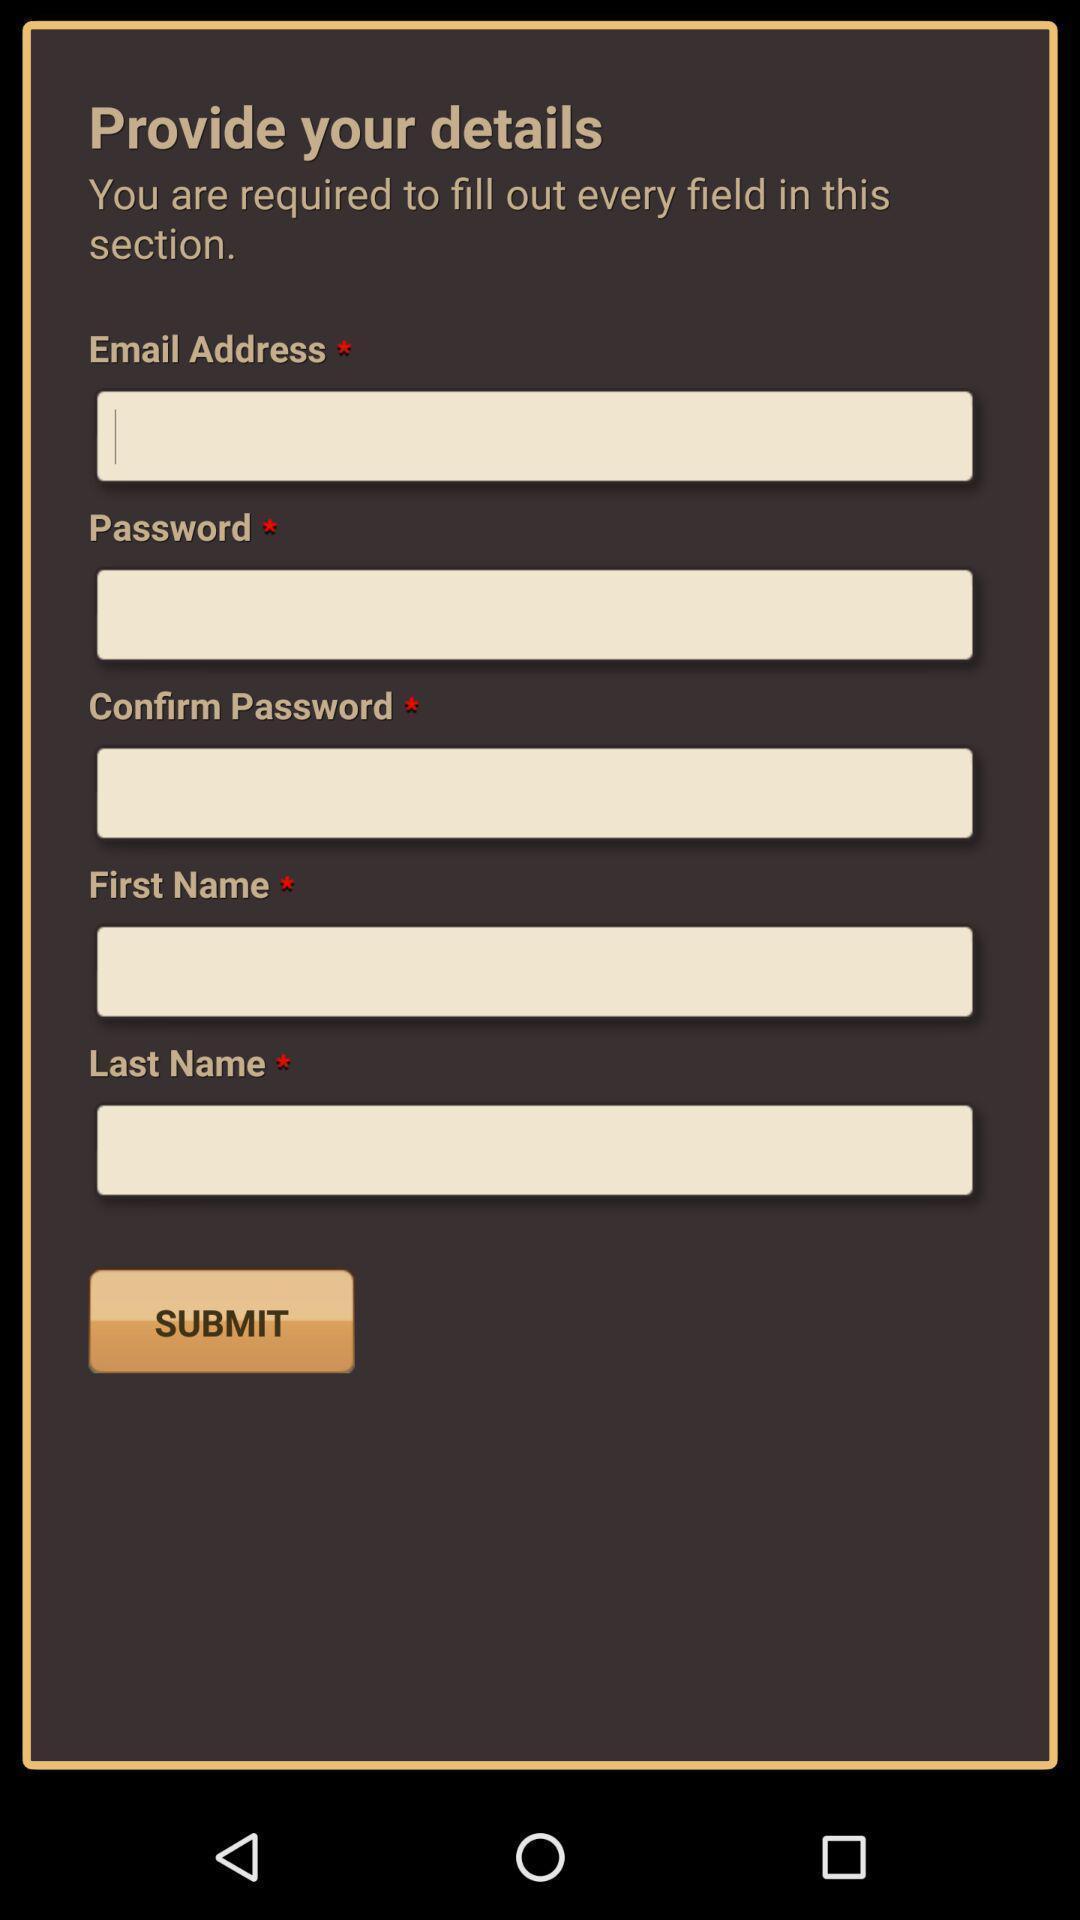Tell me what you see in this picture. Page to enter user details for an ebook app. 